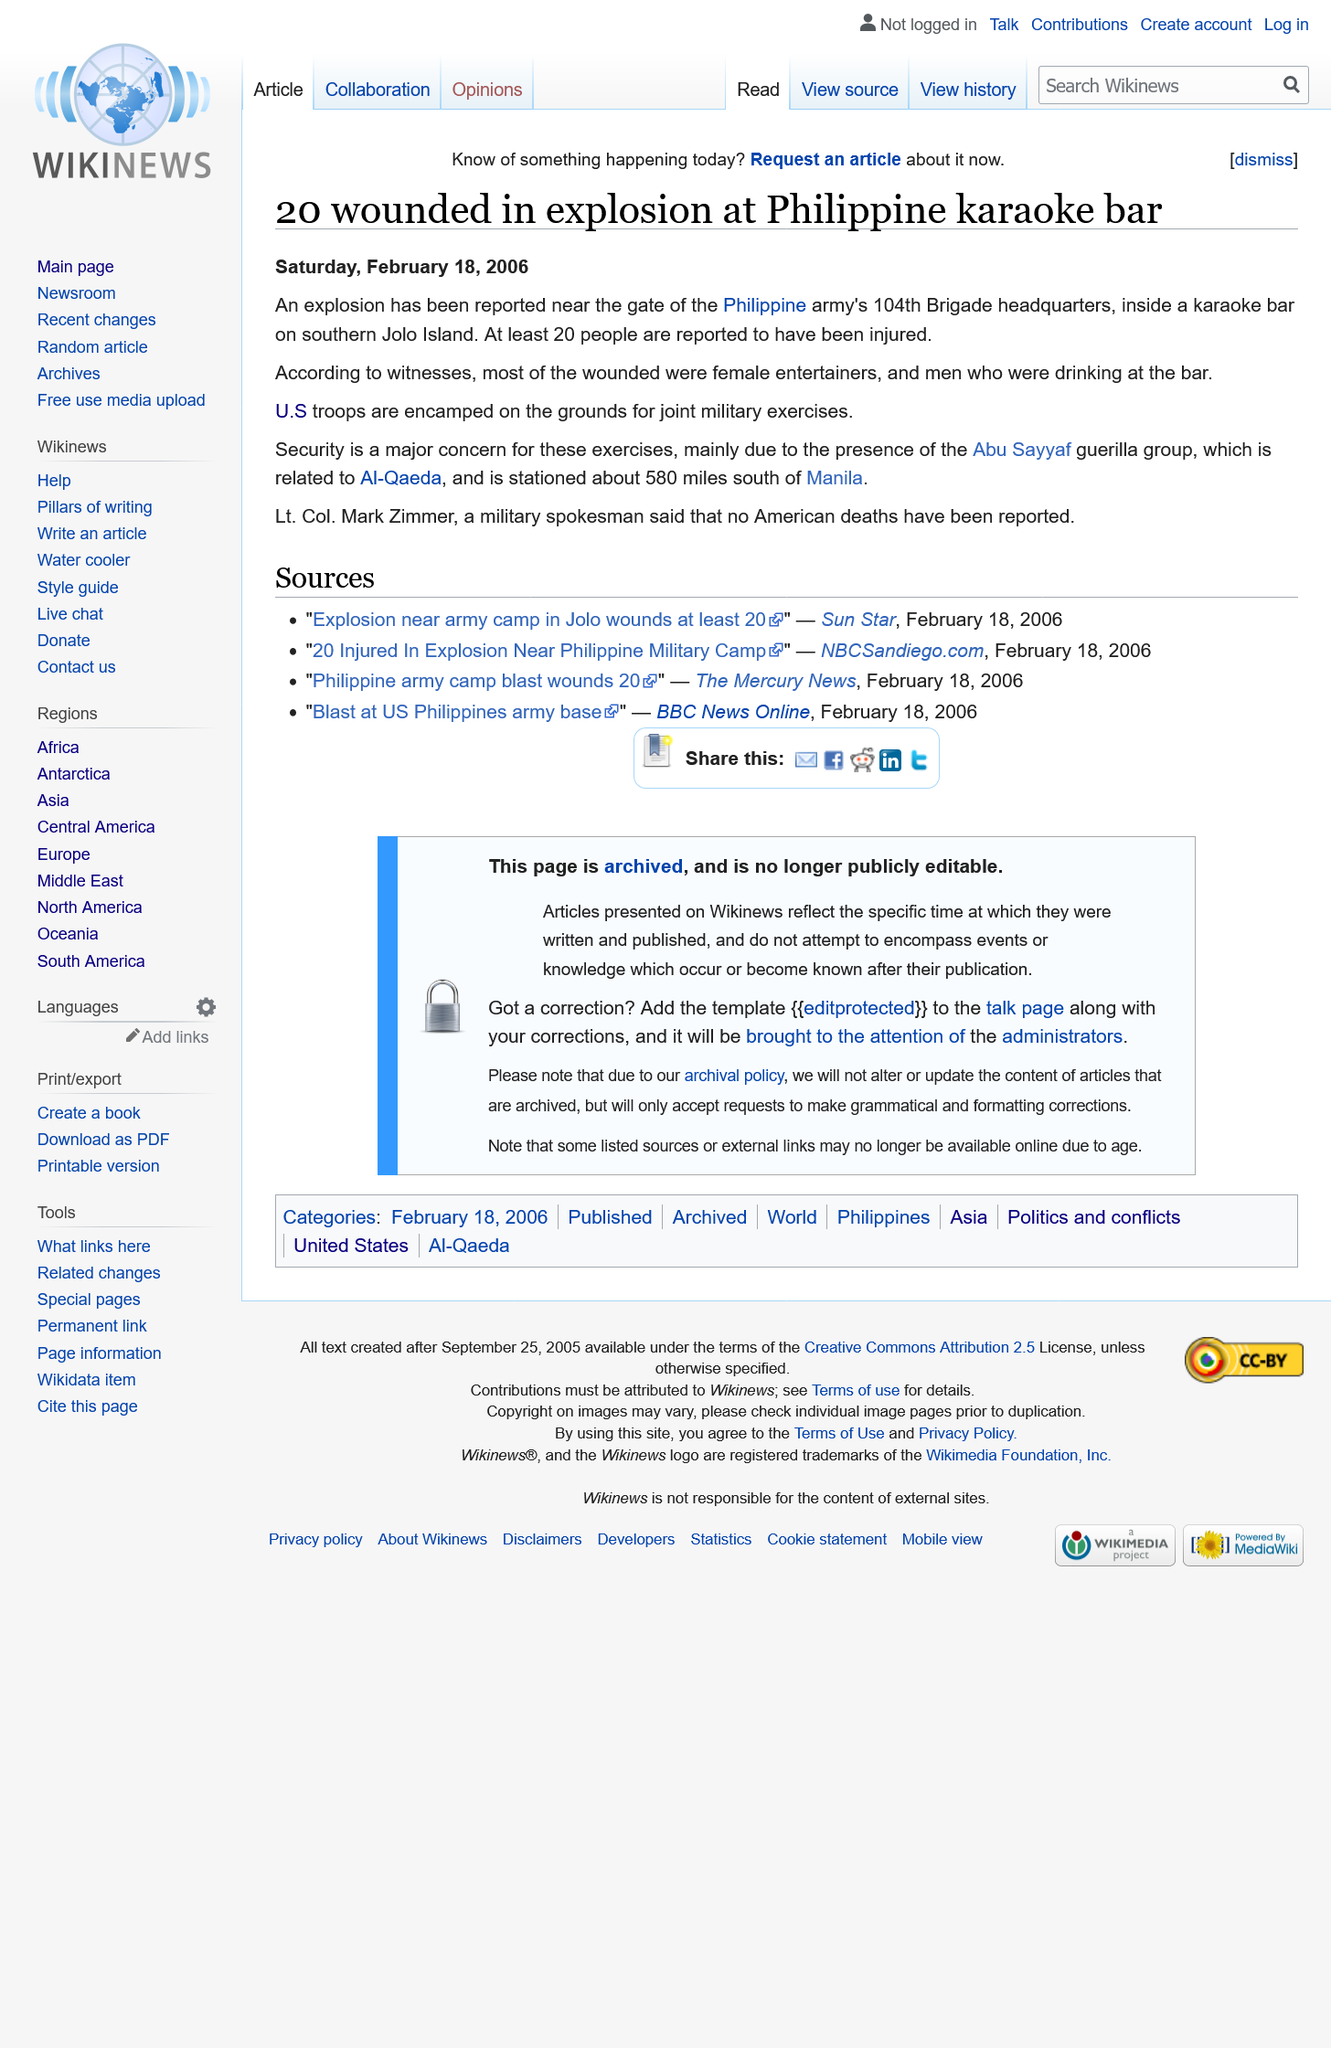Outline some significant characteristics in this image. Most of the wounded were female entertainers and men who were drinking at the bar, according to witnesses. The encampment of US troops on the grounds of the Philippine army's 104th Brigade headquarters is confirmed. To date, no American deaths have been reported as a result of the ongoing COVID-19 pandemic in the United States. 